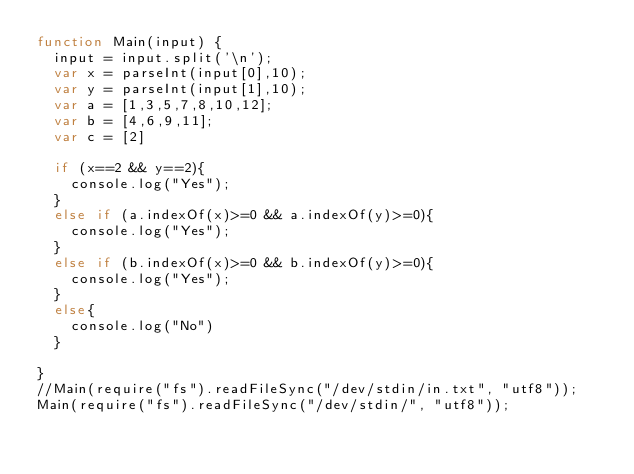Convert code to text. <code><loc_0><loc_0><loc_500><loc_500><_JavaScript_>function Main(input) {
	input = input.split('\n');
	var x = parseInt(input[0],10);
	var y = parseInt(input[1],10);
	var a = [1,3,5,7,8,10,12];
	var b = [4,6,9,11];
	var c = [2]

	if (x==2 && y==2){
		console.log("Yes");
	}
	else if (a.indexOf(x)>=0 && a.indexOf(y)>=0){
		console.log("Yes");
	}
	else if (b.indexOf(x)>=0 && b.indexOf(y)>=0){
		console.log("Yes");
	}
	else{
		console.log("No")
	}
	
}
//Main(require("fs").readFileSync("/dev/stdin/in.txt", "utf8"));
Main(require("fs").readFileSync("/dev/stdin/", "utf8"));</code> 